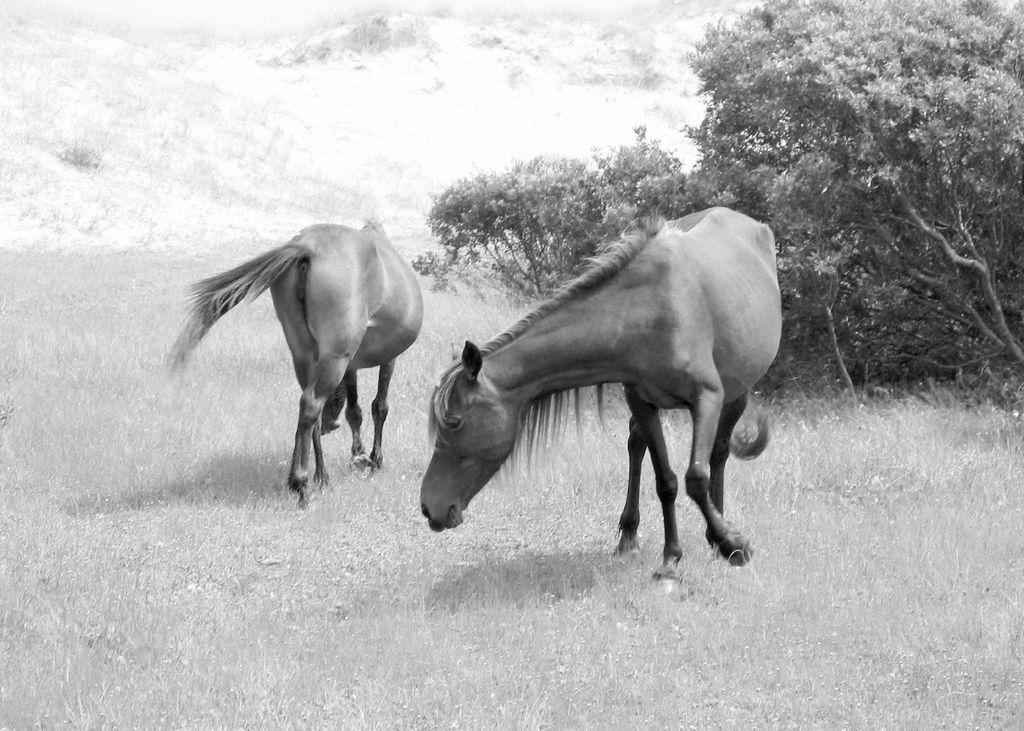What is the color scheme of the image? The image is black and white. What animals are in the center of the image? There are two horses in the center of the image. What can be seen in the background of the image? There are trees, hills, and grass in the background of the image. What type of linen is being used to clean the horses in the image? There is no linen or cleaning activity present in the image; it features two horses in a black and white setting with trees, hills, and grass in the background. 